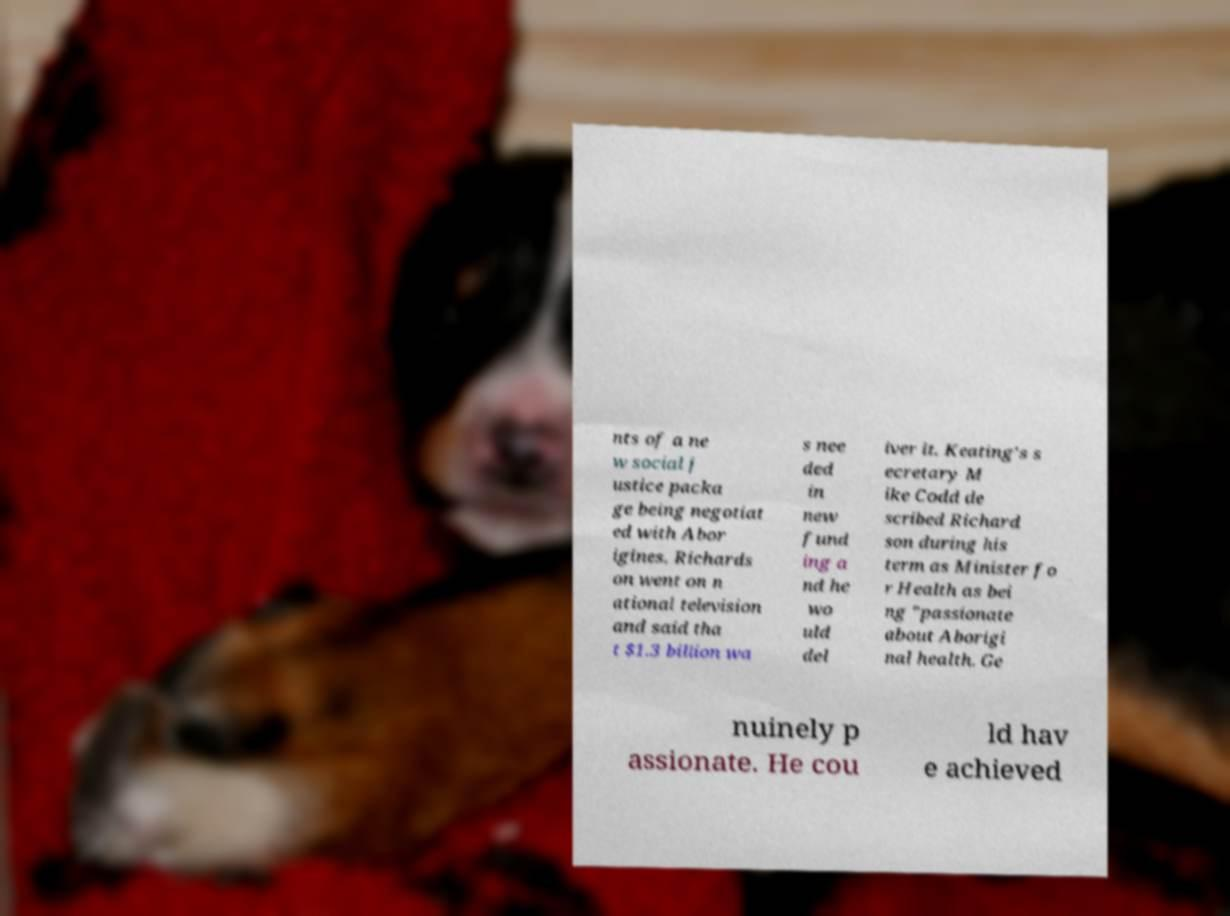Can you read and provide the text displayed in the image?This photo seems to have some interesting text. Can you extract and type it out for me? nts of a ne w social j ustice packa ge being negotiat ed with Abor igines. Richards on went on n ational television and said tha t $1.3 billion wa s nee ded in new fund ing a nd he wo uld del iver it. Keating's s ecretary M ike Codd de scribed Richard son during his term as Minister fo r Health as bei ng "passionate about Aborigi nal health. Ge nuinely p assionate. He cou ld hav e achieved 